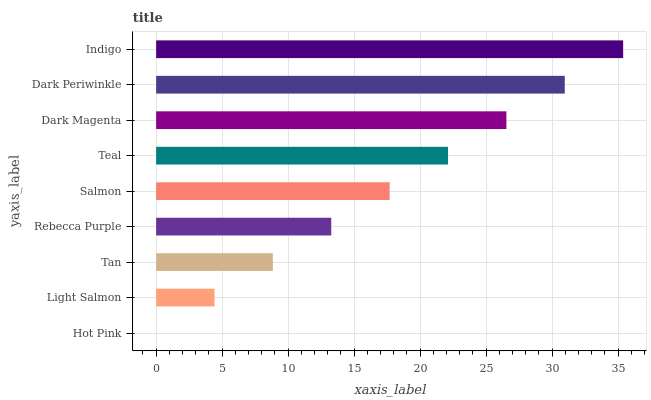Is Hot Pink the minimum?
Answer yes or no. Yes. Is Indigo the maximum?
Answer yes or no. Yes. Is Light Salmon the minimum?
Answer yes or no. No. Is Light Salmon the maximum?
Answer yes or no. No. Is Light Salmon greater than Hot Pink?
Answer yes or no. Yes. Is Hot Pink less than Light Salmon?
Answer yes or no. Yes. Is Hot Pink greater than Light Salmon?
Answer yes or no. No. Is Light Salmon less than Hot Pink?
Answer yes or no. No. Is Salmon the high median?
Answer yes or no. Yes. Is Salmon the low median?
Answer yes or no. Yes. Is Tan the high median?
Answer yes or no. No. Is Light Salmon the low median?
Answer yes or no. No. 